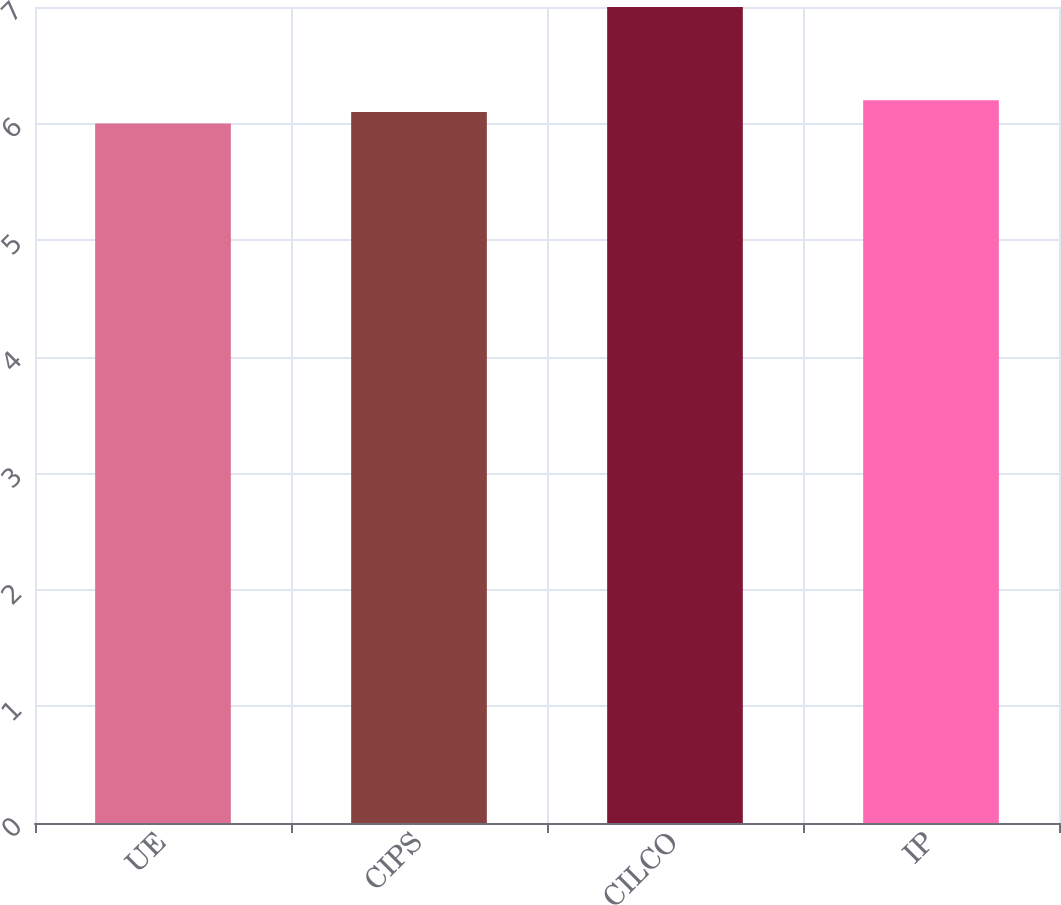Convert chart. <chart><loc_0><loc_0><loc_500><loc_500><bar_chart><fcel>UE<fcel>CIPS<fcel>CILCO<fcel>IP<nl><fcel>6<fcel>6.1<fcel>7<fcel>6.2<nl></chart> 